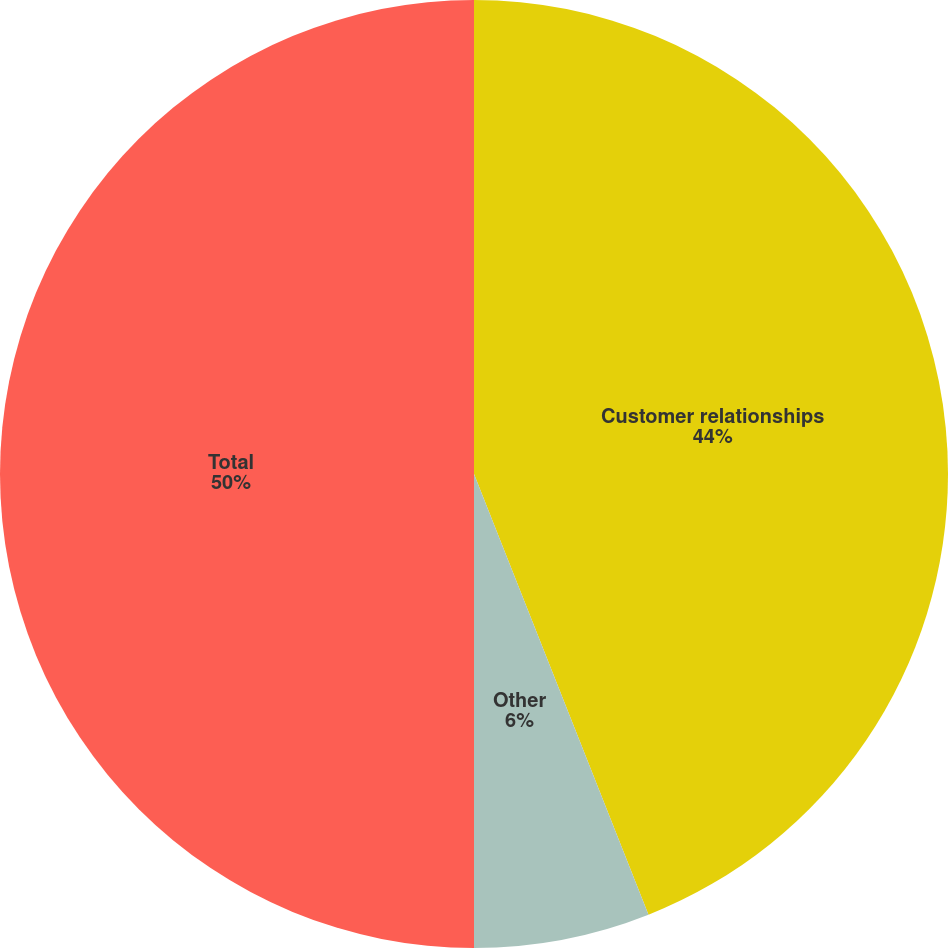Convert chart to OTSL. <chart><loc_0><loc_0><loc_500><loc_500><pie_chart><fcel>Customer relationships<fcel>Other<fcel>Total<nl><fcel>44.0%<fcel>6.0%<fcel>50.0%<nl></chart> 